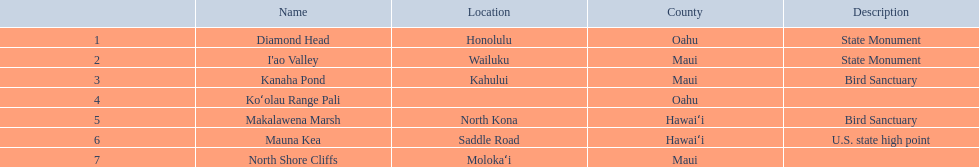How many locations are bird sanctuaries. 2. 